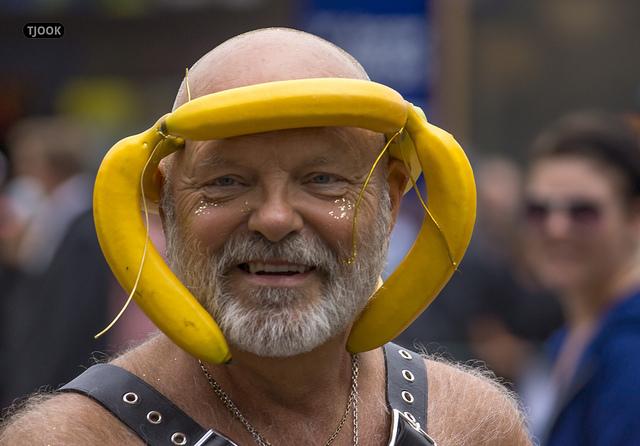What is the man holding?
Answer briefly. Bananas. Is the man trying to look funny?
Keep it brief. Yes. Is the man bald?
Be succinct. Yes. What is on his head?
Keep it brief. Bananas. 